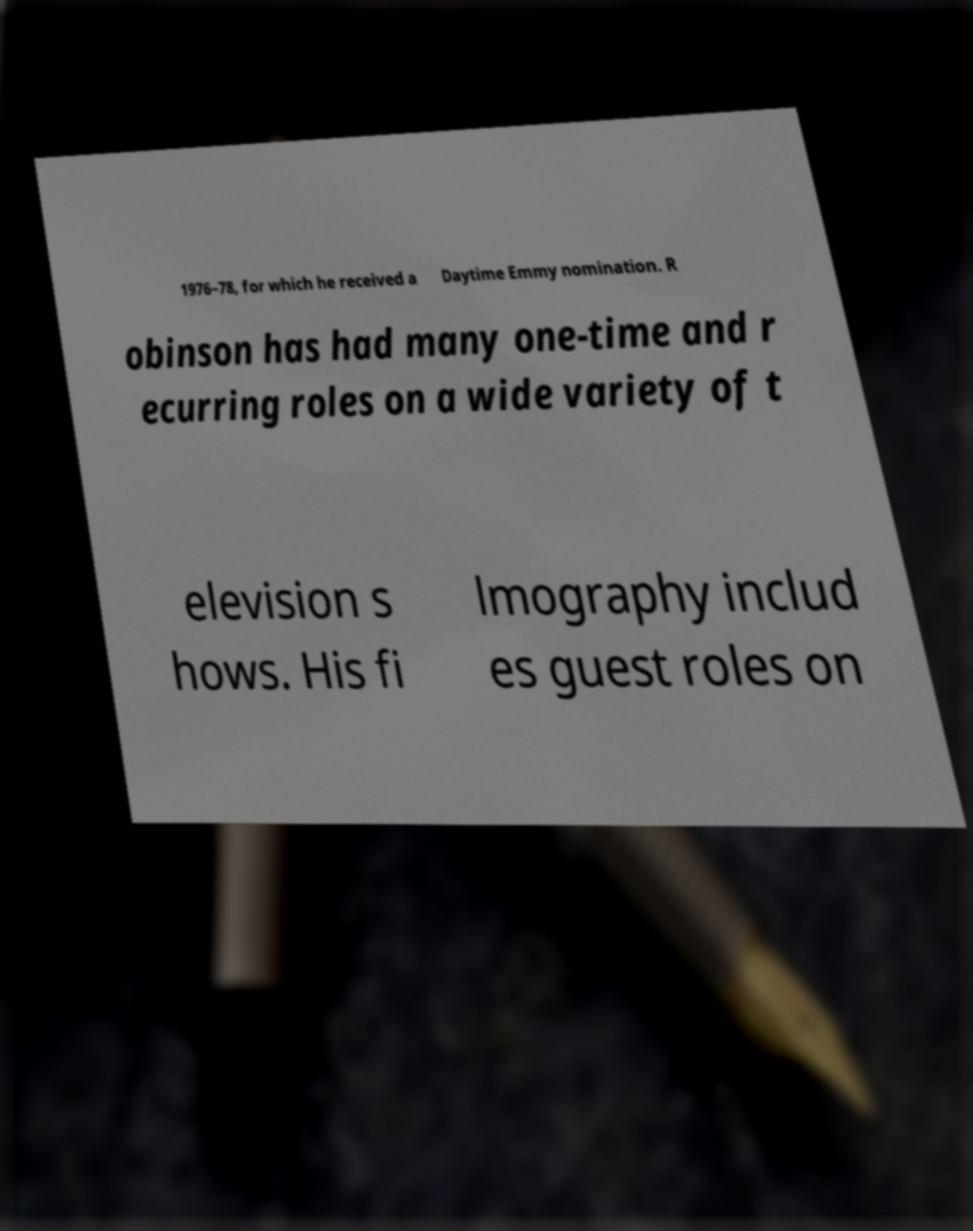For documentation purposes, I need the text within this image transcribed. Could you provide that? 1976–78, for which he received a Daytime Emmy nomination. R obinson has had many one-time and r ecurring roles on a wide variety of t elevision s hows. His fi lmography includ es guest roles on 